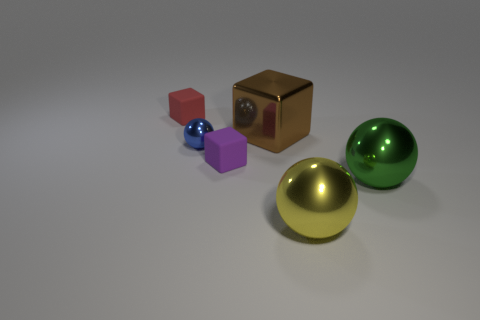The large shiny sphere in front of the green metal thing is what color? The large shiny sphere is a radiant yellow, displaying a lustrous finish that captures and reflects the light, highlighting its smooth and almost perfect spherical surface. 